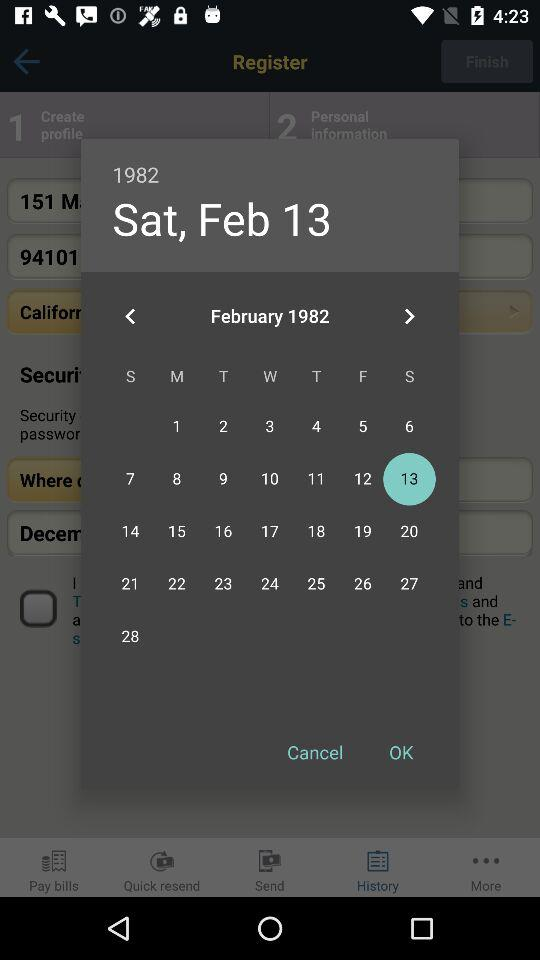How many days are there in this month?
Answer the question using a single word or phrase. 28 